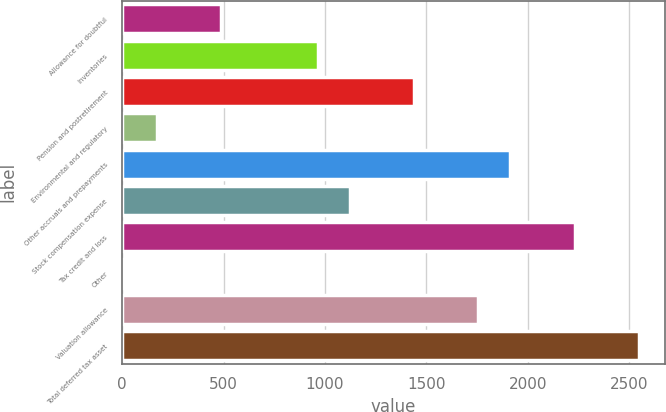Convert chart. <chart><loc_0><loc_0><loc_500><loc_500><bar_chart><fcel>Allowance for doubtful<fcel>Inventories<fcel>Pension and postretirement<fcel>Environmental and regulatory<fcel>Other accruals and prepayments<fcel>Stock compensation expense<fcel>Tax credit and loss<fcel>Other<fcel>Valuation allowance<fcel>Total deferred tax asset<nl><fcel>489.92<fcel>964.64<fcel>1439.36<fcel>173.44<fcel>1914.08<fcel>1122.88<fcel>2230.56<fcel>15.2<fcel>1755.84<fcel>2547.04<nl></chart> 